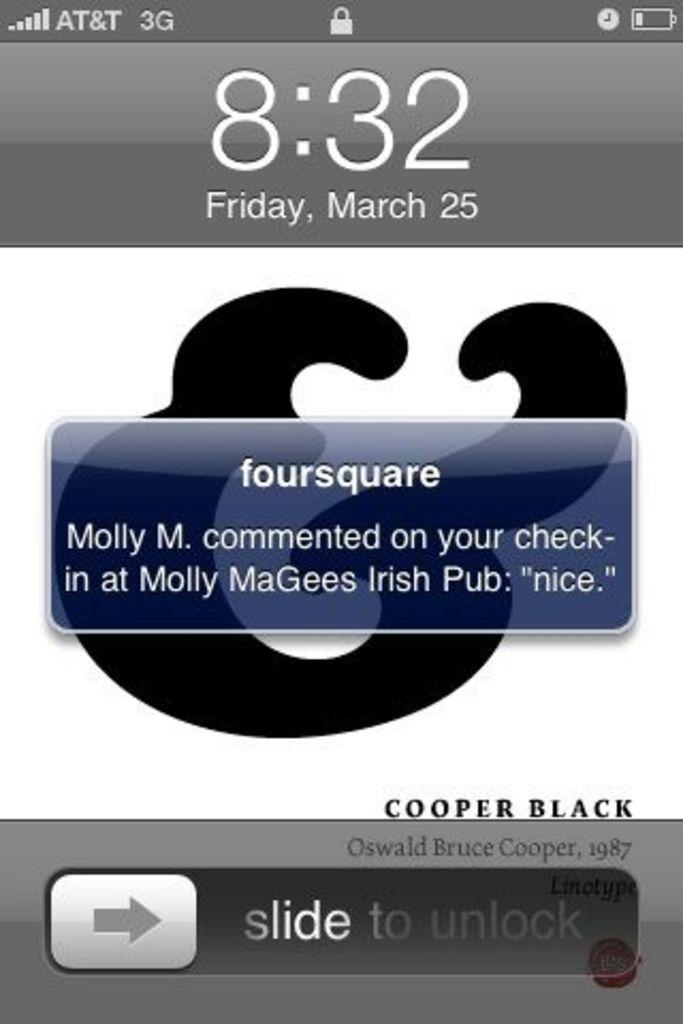What app is sending a message?
Keep it short and to the point. Foursquare. 